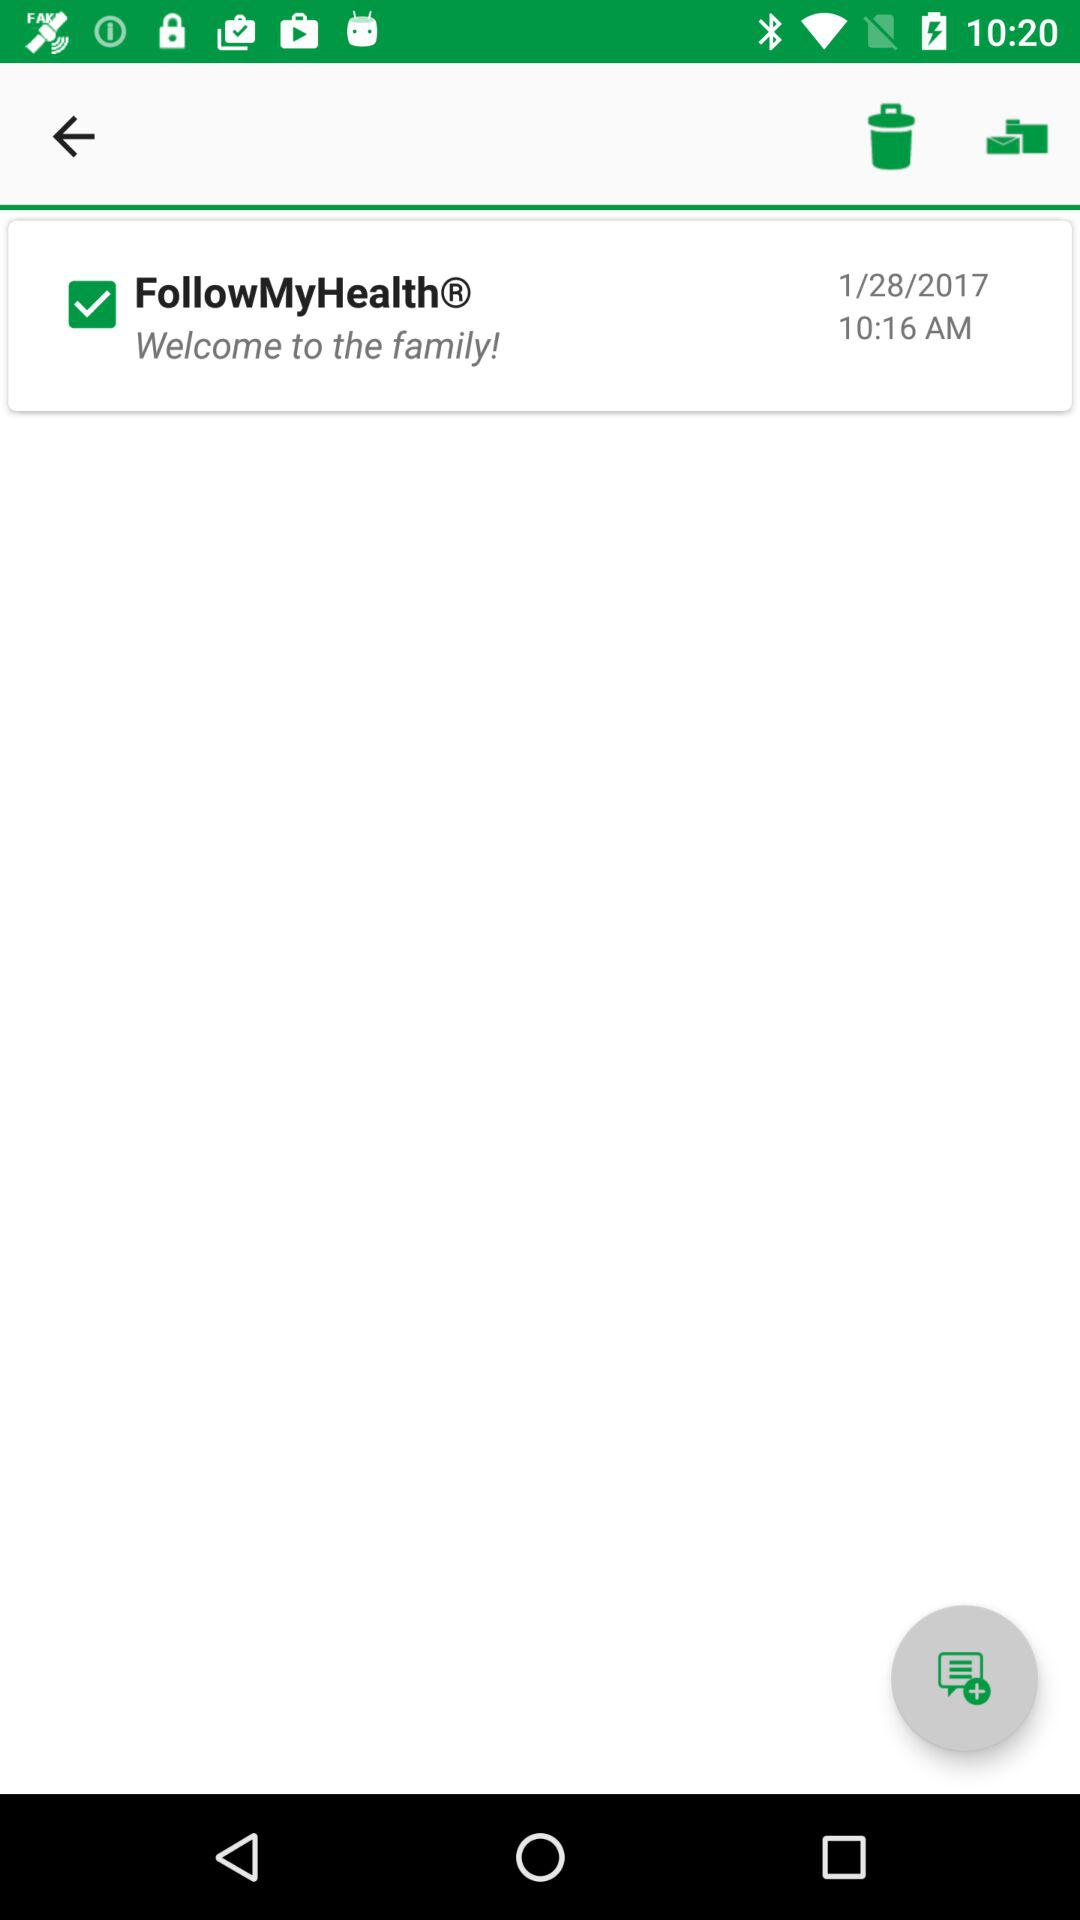What is the date? The date is January 28, 2017. 